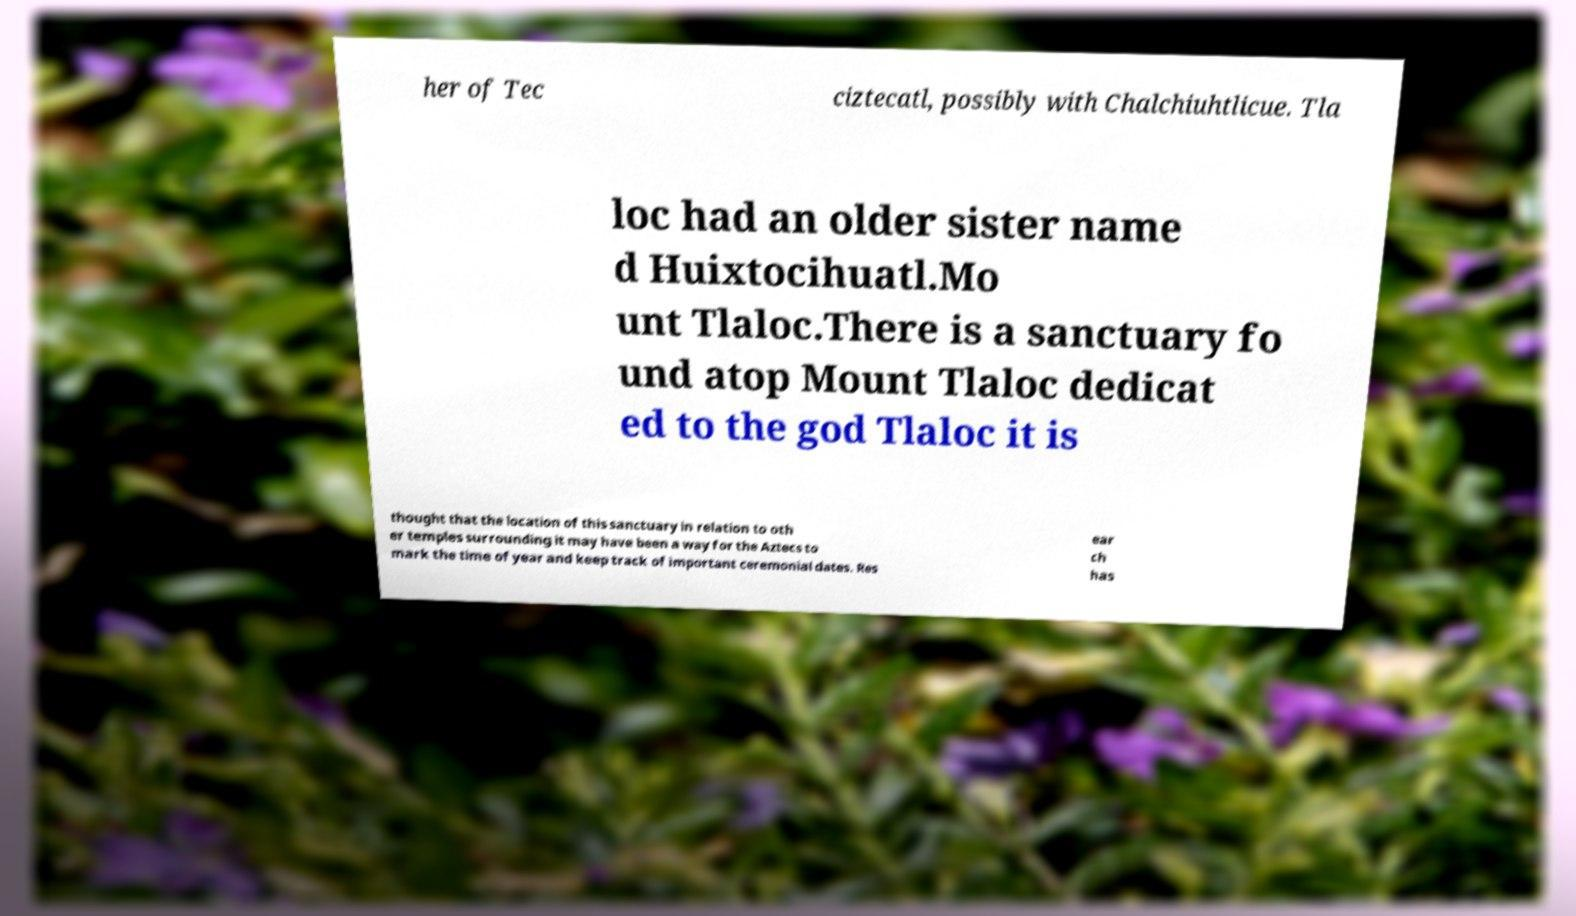Can you read and provide the text displayed in the image?This photo seems to have some interesting text. Can you extract and type it out for me? her of Tec ciztecatl, possibly with Chalchiuhtlicue. Tla loc had an older sister name d Huixtocihuatl.Mo unt Tlaloc.There is a sanctuary fo und atop Mount Tlaloc dedicat ed to the god Tlaloc it is thought that the location of this sanctuary in relation to oth er temples surrounding it may have been a way for the Aztecs to mark the time of year and keep track of important ceremonial dates. Res ear ch has 